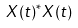<formula> <loc_0><loc_0><loc_500><loc_500>X ( t ) ^ { * } X ( t )</formula> 